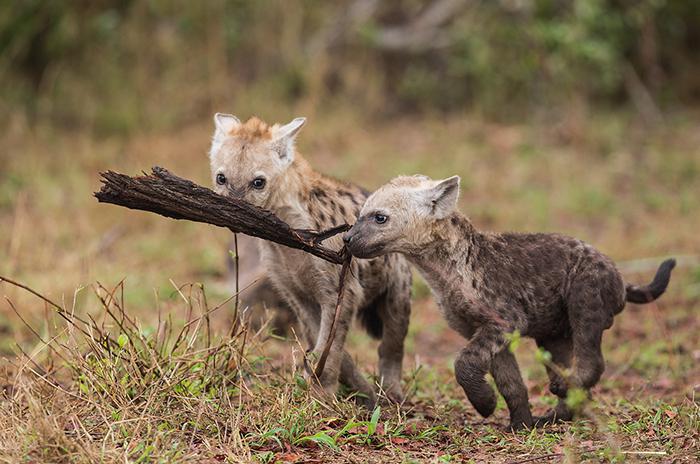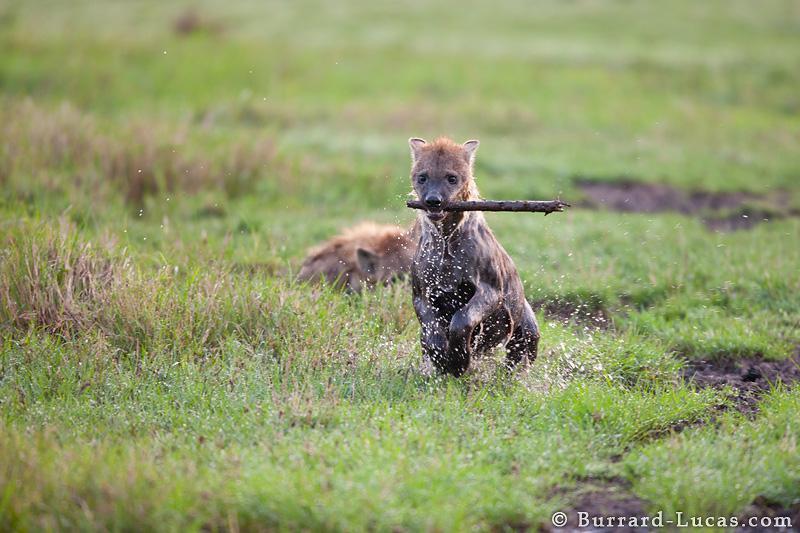The first image is the image on the left, the second image is the image on the right. Considering the images on both sides, is "At least one image shows an upright young hyena with something that is not part of a prey animal held in its mouth." valid? Answer yes or no. Yes. The first image is the image on the left, the second image is the image on the right. For the images displayed, is the sentence "The left image contains two hyenas." factually correct? Answer yes or no. Yes. 